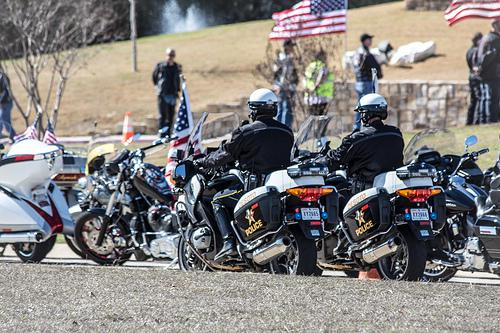Question: what are the police doing?
Choices:
A. Riding bikes.
B. Riding Segways.
C. Riding motorcycles.
D. Riding scooters.
Answer with the letter. Answer: C Question: who is on the hill?
Choices:
A. Spectators.
B. Visitors.
C. Customers.
D. Vendors.
Answer with the letter. Answer: A Question: what is on the hill?
Choices:
A. American flags.
B. Italian flags.
C. British flags.
D. Mexican flags.
Answer with the letter. Answer: A Question: why are the police riding?
Choices:
A. A funeral escort.
B. A presidential escort.
C. A wide load escort.
D. An emergency escort.
Answer with the letter. Answer: A 